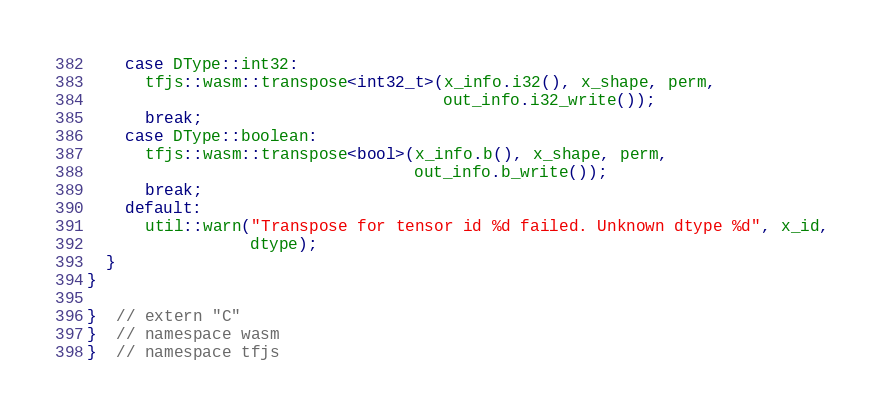<code> <loc_0><loc_0><loc_500><loc_500><_C++_>    case DType::int32:
      tfjs::wasm::transpose<int32_t>(x_info.i32(), x_shape, perm,
                                     out_info.i32_write());
      break;
    case DType::boolean:
      tfjs::wasm::transpose<bool>(x_info.b(), x_shape, perm,
                                  out_info.b_write());
      break;
    default:
      util::warn("Transpose for tensor id %d failed. Unknown dtype %d", x_id,
                 dtype);
  }
}

}  // extern "C"
}  // namespace wasm
}  // namespace tfjs
</code> 